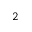<formula> <loc_0><loc_0><loc_500><loc_500>^ { 2 }</formula> 